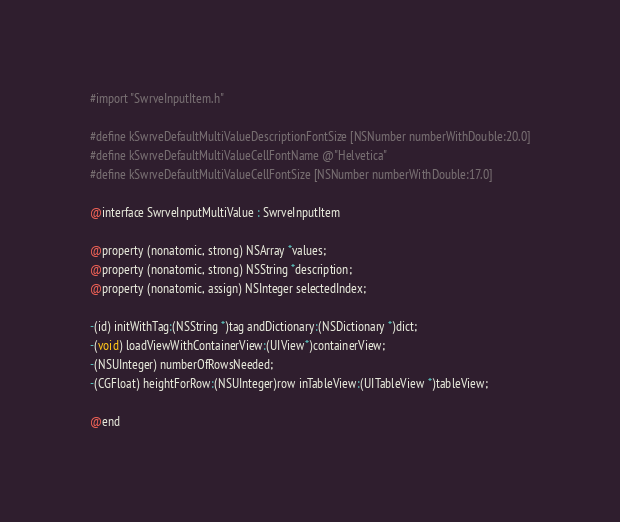<code> <loc_0><loc_0><loc_500><loc_500><_C_>#import "SwrveInputItem.h"

#define kSwrveDefaultMultiValueDescriptionFontSize [NSNumber numberWithDouble:20.0]
#define kSwrveDefaultMultiValueCellFontName @"Helvetica"
#define kSwrveDefaultMultiValueCellFontSize [NSNumber numberWithDouble:17.0]

@interface SwrveInputMultiValue : SwrveInputItem

@property (nonatomic, strong) NSArray *values;
@property (nonatomic, strong) NSString *description;
@property (nonatomic, assign) NSInteger selectedIndex;

-(id) initWithTag:(NSString *)tag andDictionary:(NSDictionary *)dict;
-(void) loadViewWithContainerView:(UIView*)containerView;
-(NSUInteger) numberOfRowsNeeded;
-(CGFloat) heightForRow:(NSUInteger)row inTableView:(UITableView *)tableView;

@end
</code> 